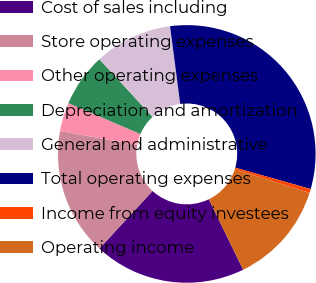<chart> <loc_0><loc_0><loc_500><loc_500><pie_chart><fcel>Cost of sales including<fcel>Store operating expenses<fcel>Other operating expenses<fcel>Depreciation and amortization<fcel>General and administrative<fcel>Total operating expenses<fcel>Income from equity investees<fcel>Operating income<nl><fcel>19.08%<fcel>15.98%<fcel>3.6%<fcel>6.69%<fcel>9.79%<fcel>31.47%<fcel>0.5%<fcel>12.89%<nl></chart> 